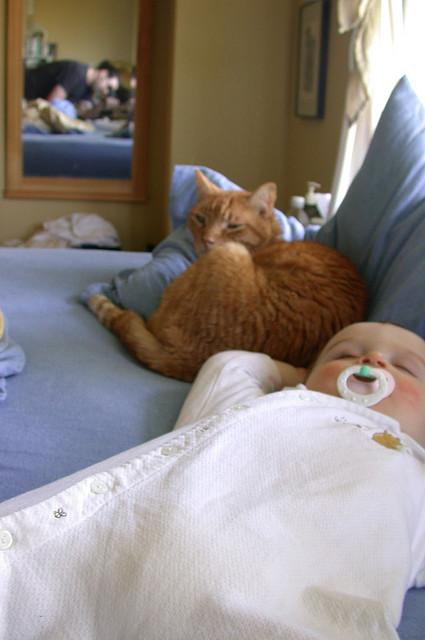What does the baby have in their mouth?
Quick response, please. Pacifier. Where is the cat and the baby?
Give a very brief answer. Bed. How old is the baby?
Short answer required. Young. What is tribal?
Give a very brief answer. Nothing. 